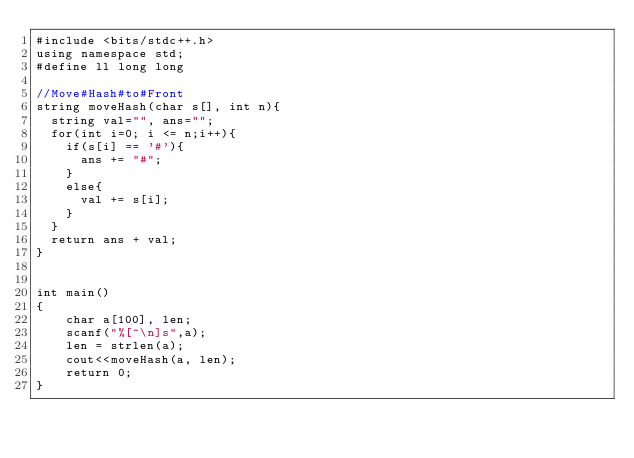Convert code to text. <code><loc_0><loc_0><loc_500><loc_500><_C++_>#include <bits/stdc++.h>
using namespace std;
#define ll long long

//Move#Hash#to#Front
string moveHash(char s[], int n){
  string val="", ans="";
  for(int i=0; i <= n;i++){
    if(s[i] == '#'){
      ans += "#";
    }
    else{
      val += s[i];
    }
  }
  return ans + val;
}


int main()
{
    char a[100], len;
    scanf("%[^\n]s",a);
    len = strlen(a);
    cout<<moveHash(a, len);
    return 0;
}
</code> 